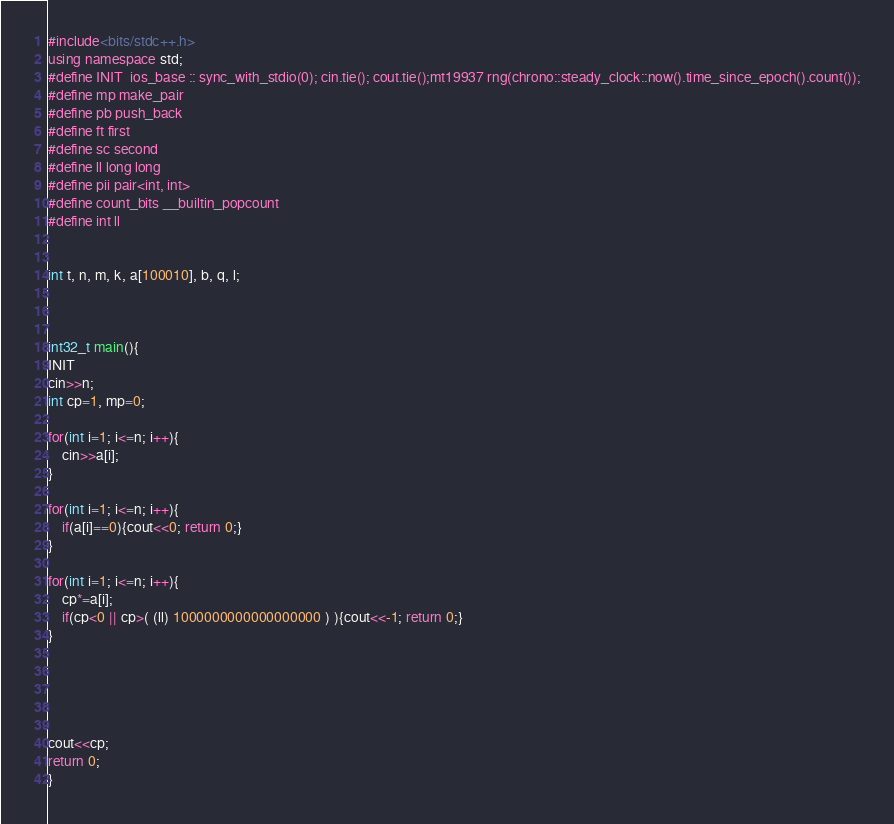<code> <loc_0><loc_0><loc_500><loc_500><_C++_>#include<bits/stdc++.h>
using namespace std;
#define INIT  ios_base :: sync_with_stdio(0); cin.tie(); cout.tie();mt19937 rng(chrono::steady_clock::now().time_since_epoch().count());
#define mp make_pair
#define pb push_back
#define ft first
#define sc second
#define ll long long
#define pii pair<int, int>
#define count_bits __builtin_popcount
#define int ll


int t, n, m, k, a[100010], b, q, l;



int32_t main(){
INIT
cin>>n;
int cp=1, mp=0;

for(int i=1; i<=n; i++){
    cin>>a[i];
}

for(int i=1; i<=n; i++){
    if(a[i]==0){cout<<0; return 0;}
}

for(int i=1; i<=n; i++){
    cp*=a[i];
    if(cp<0 || cp>( (ll) 1000000000000000000 ) ){cout<<-1; return 0;}
}





cout<<cp;
return 0;
}
</code> 